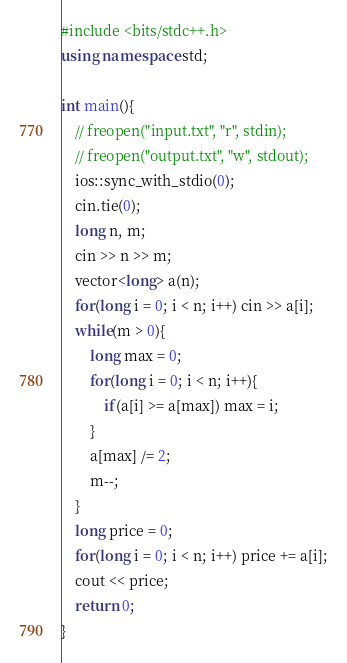<code> <loc_0><loc_0><loc_500><loc_500><_C++_>#include <bits/stdc++.h>
using namespace std;

int main(){
    // freopen("input.txt", "r", stdin);
    // freopen("output.txt", "w", stdout);
	ios::sync_with_stdio(0);
    cin.tie(0);
    long n, m;
    cin >> n >> m;
    vector<long> a(n);
    for(long i = 0; i < n; i++) cin >> a[i];
    while(m > 0){
        long max = 0;
        for(long i = 0; i < n; i++){
            if(a[i] >= a[max]) max = i;
        }
        a[max] /= 2;
        m--;
    }
    long price = 0;
    for(long i = 0; i < n; i++) price += a[i];
    cout << price;
    return 0;
}
</code> 